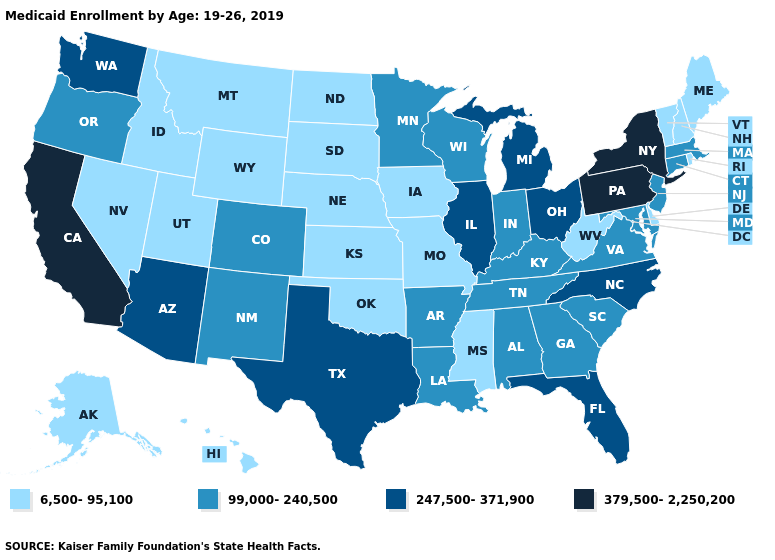Does the first symbol in the legend represent the smallest category?
Quick response, please. Yes. Which states have the highest value in the USA?
Answer briefly. California, New York, Pennsylvania. Does Oklahoma have a lower value than Oregon?
Quick response, please. Yes. Name the states that have a value in the range 99,000-240,500?
Concise answer only. Alabama, Arkansas, Colorado, Connecticut, Georgia, Indiana, Kentucky, Louisiana, Maryland, Massachusetts, Minnesota, New Jersey, New Mexico, Oregon, South Carolina, Tennessee, Virginia, Wisconsin. Does South Carolina have the lowest value in the South?
Keep it brief. No. Among the states that border Tennessee , which have the lowest value?
Be succinct. Mississippi, Missouri. What is the value of Arkansas?
Quick response, please. 99,000-240,500. What is the lowest value in states that border Arkansas?
Concise answer only. 6,500-95,100. Among the states that border South Carolina , which have the lowest value?
Keep it brief. Georgia. Name the states that have a value in the range 99,000-240,500?
Give a very brief answer. Alabama, Arkansas, Colorado, Connecticut, Georgia, Indiana, Kentucky, Louisiana, Maryland, Massachusetts, Minnesota, New Jersey, New Mexico, Oregon, South Carolina, Tennessee, Virginia, Wisconsin. Does Utah have the highest value in the USA?
Concise answer only. No. Name the states that have a value in the range 6,500-95,100?
Short answer required. Alaska, Delaware, Hawaii, Idaho, Iowa, Kansas, Maine, Mississippi, Missouri, Montana, Nebraska, Nevada, New Hampshire, North Dakota, Oklahoma, Rhode Island, South Dakota, Utah, Vermont, West Virginia, Wyoming. Name the states that have a value in the range 379,500-2,250,200?
Quick response, please. California, New York, Pennsylvania. 